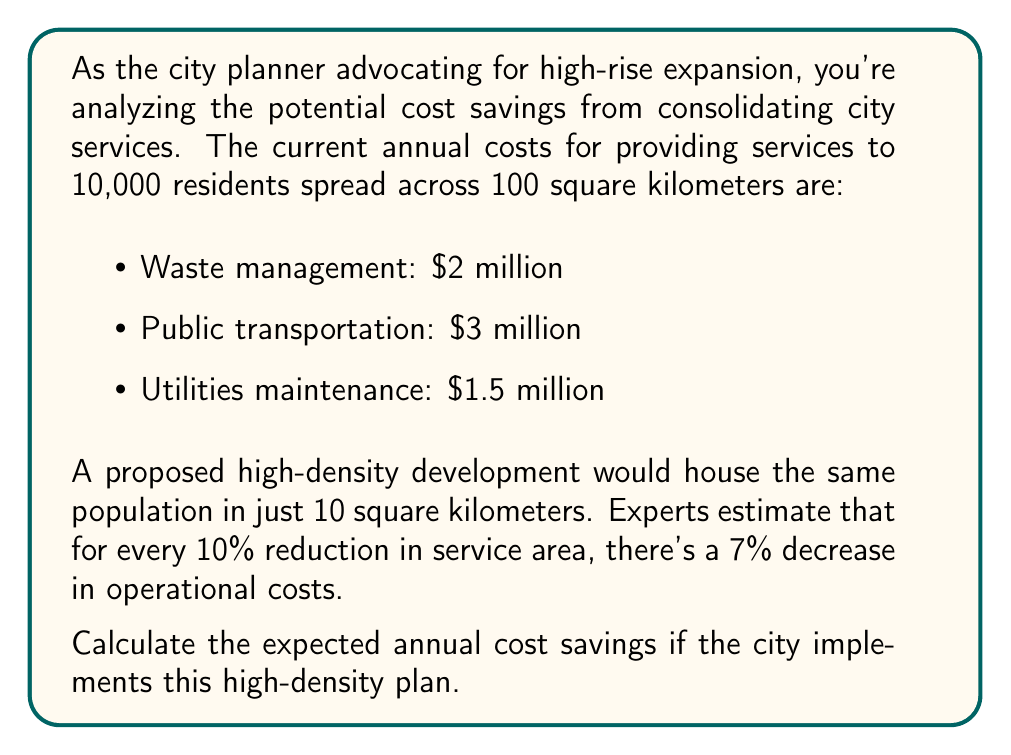Can you solve this math problem? Let's approach this step-by-step:

1) First, calculate the reduction in service area:
   $$\text{Reduction} = \frac{100 \text{ km}^2 - 10 \text{ km}^2}{100 \text{ km}^2} \times 100\% = 90\%$$

2) For every 10% reduction, there's a 7% decrease in costs. So for 90% reduction:
   $$\text{Cost decrease} = 90\% \times \frac{7\%}{10\%} = 63\%$$

3) Current total annual costs:
   $$2,000,000 + 3,000,000 + 1,500,000 = \$6,500,000$$

4) Expected costs after consolidation:
   $$\$6,500,000 \times (1 - 0.63) = \$2,405,000$$

5) Calculate the annual savings:
   $$\$6,500,000 - \$2,405,000 = \$4,095,000$$

Thus, the expected annual cost savings would be $4,095,000.
Answer: $4,095,000 